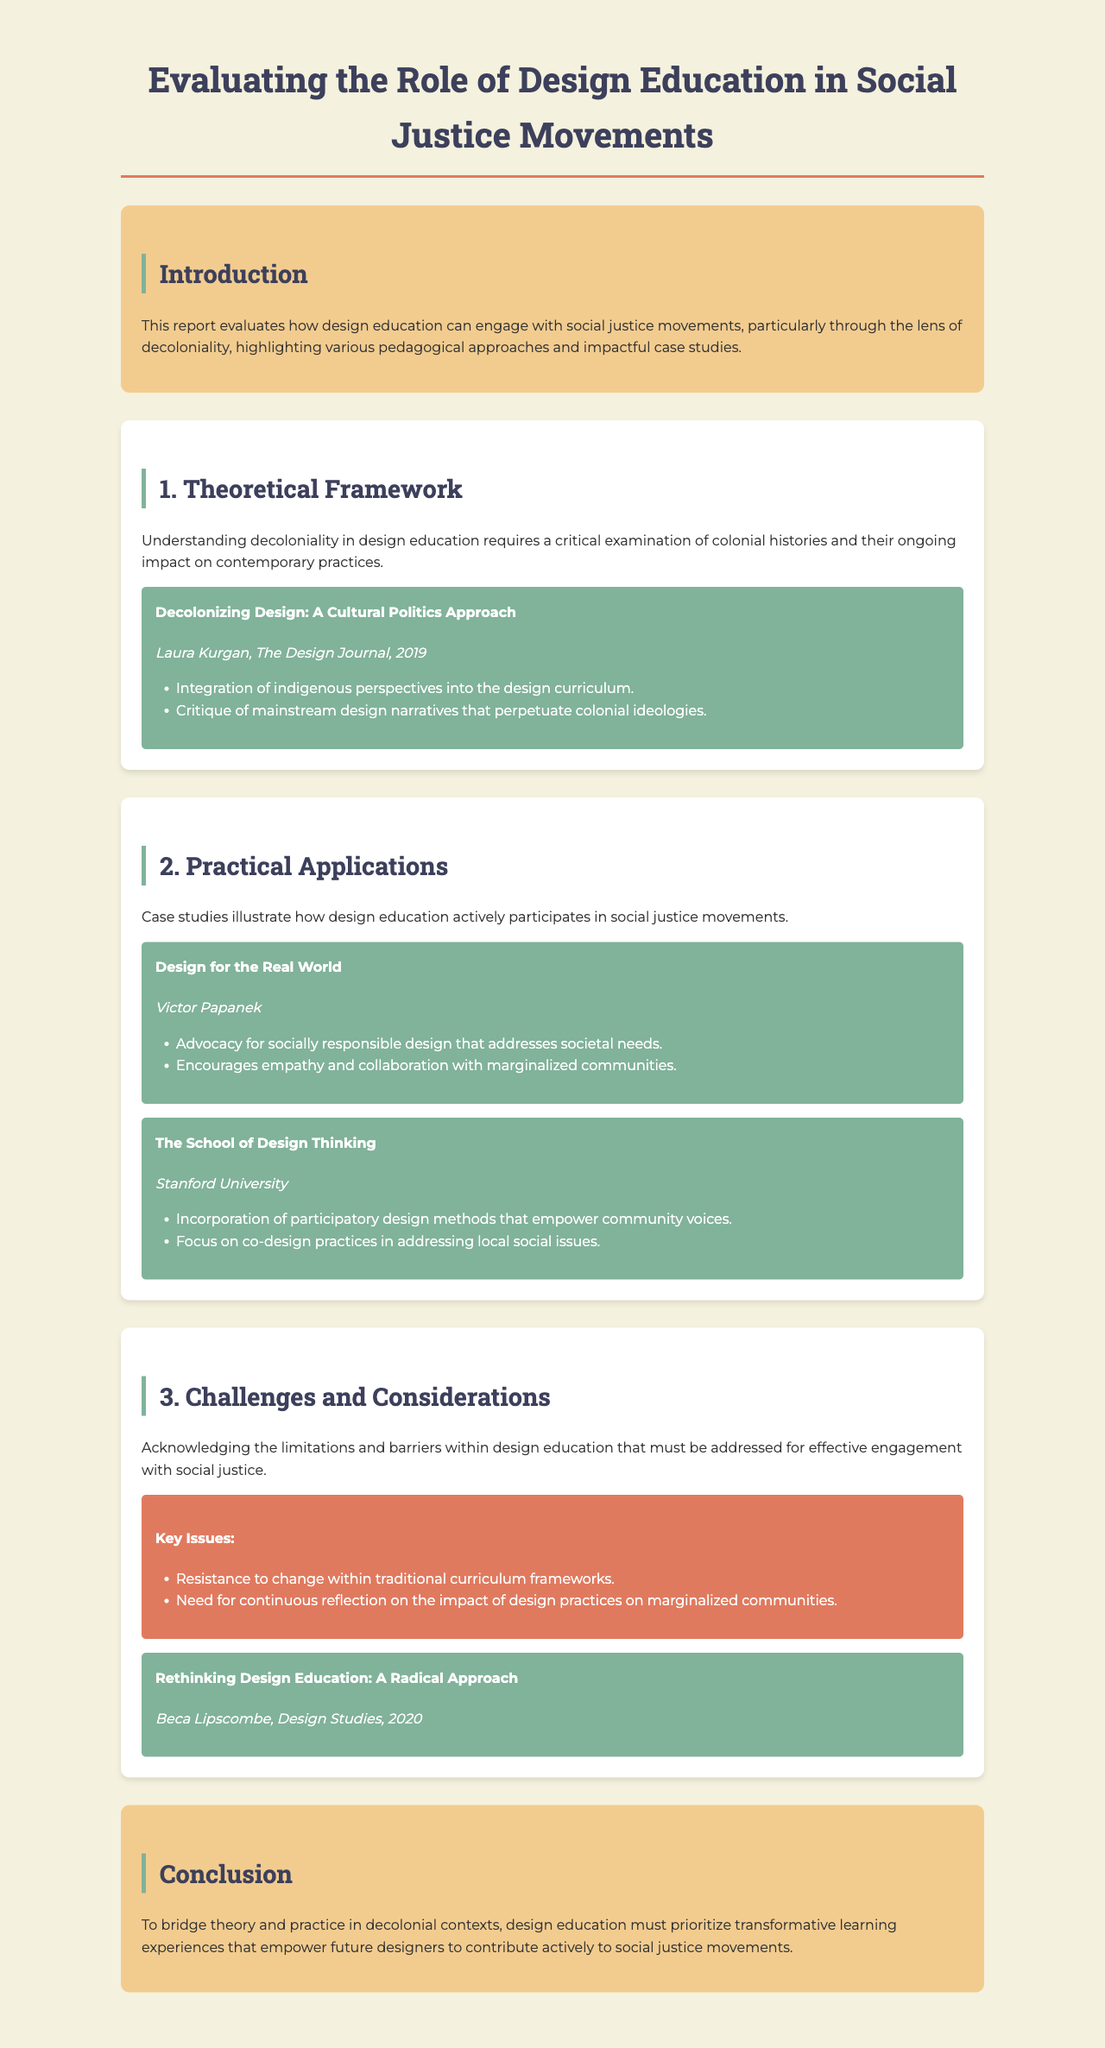What is the title of the report? The title is presented prominently at the beginning of the document, which encapsulates the focus on design education and social justice.
Answer: Evaluating the Role of Design Education in Social Justice Movements Who authored "Decolonizing Design: A Cultural Politics Approach"? The document cites Laura Kurgan as the author of this reference, which is part of the theoretical framework.
Answer: Laura Kurgan What is one of the key issues identified in the challenges section? The challenges section explicitly lists multiple issues, with one specified being "Resistance to change within traditional curriculum frameworks."
Answer: Resistance to change within traditional curriculum frameworks Which educational institution is mentioned in association with participatory design methods? The document refers to Stanford University in connection with an example study.
Answer: Stanford University What year was "Rethinking Design Education: A Radical Approach" published? The publication year of this reference is listed in the document, providing insight into the recent discussions on design education.
Answer: 2020 What is emphasized in the conclusion for the future of design education? The conclusion highlights the importance of "transformative learning experiences" as a way to advance the field of design education toward social justice.
Answer: Transformative learning experiences What does Victor Papanek advocate for in his example? The document mentions that Victor Papanek's advocacy focuses on "socially responsible design that addresses societal needs."
Answer: Socially responsible design that addresses societal needs What approach does "The School of Design Thinking" incorporate? The document notes the incorporation of participatory design methods as a significant aspect of this educational approach.
Answer: Participatory design methods 